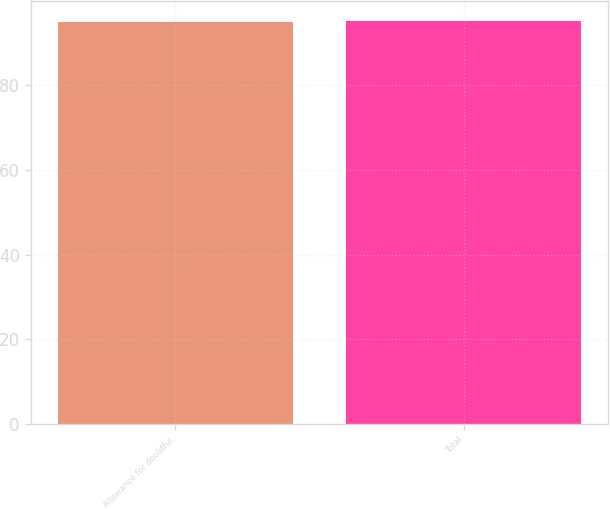Convert chart. <chart><loc_0><loc_0><loc_500><loc_500><bar_chart><fcel>Allowance for doubtful<fcel>Total<nl><fcel>95<fcel>95.1<nl></chart> 